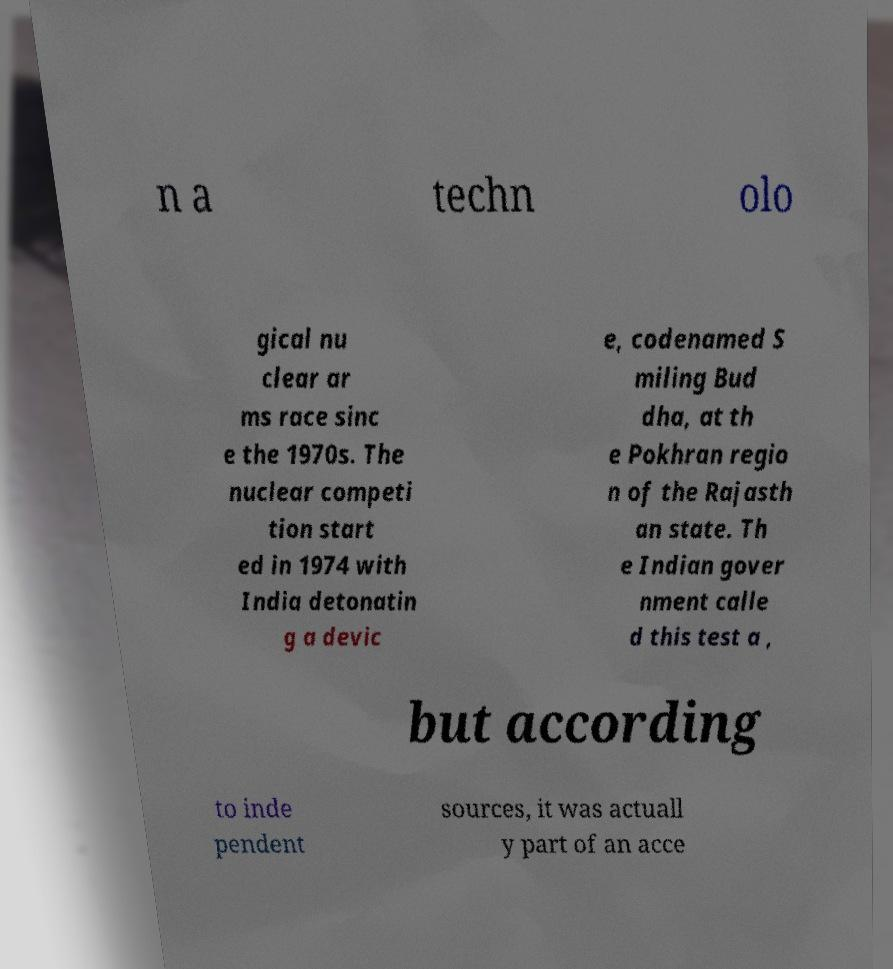I need the written content from this picture converted into text. Can you do that? n a techn olo gical nu clear ar ms race sinc e the 1970s. The nuclear competi tion start ed in 1974 with India detonatin g a devic e, codenamed S miling Bud dha, at th e Pokhran regio n of the Rajasth an state. Th e Indian gover nment calle d this test a , but according to inde pendent sources, it was actuall y part of an acce 